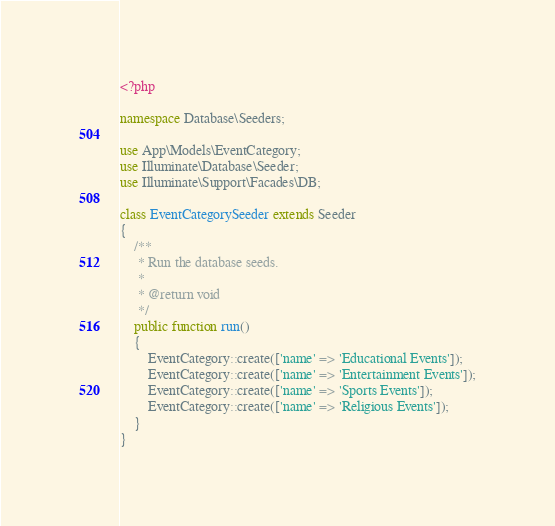Convert code to text. <code><loc_0><loc_0><loc_500><loc_500><_PHP_><?php

namespace Database\Seeders;

use App\Models\EventCategory;
use Illuminate\Database\Seeder;
use Illuminate\Support\Facades\DB;

class EventCategorySeeder extends Seeder
{
    /**
     * Run the database seeds.
     *
     * @return void
     */
    public function run()
    {
        EventCategory::create(['name' => 'Educational Events']);
        EventCategory::create(['name' => 'Entertainment Events']);
        EventCategory::create(['name' => 'Sports Events']);
        EventCategory::create(['name' => 'Religious Events']);
    }
}
</code> 